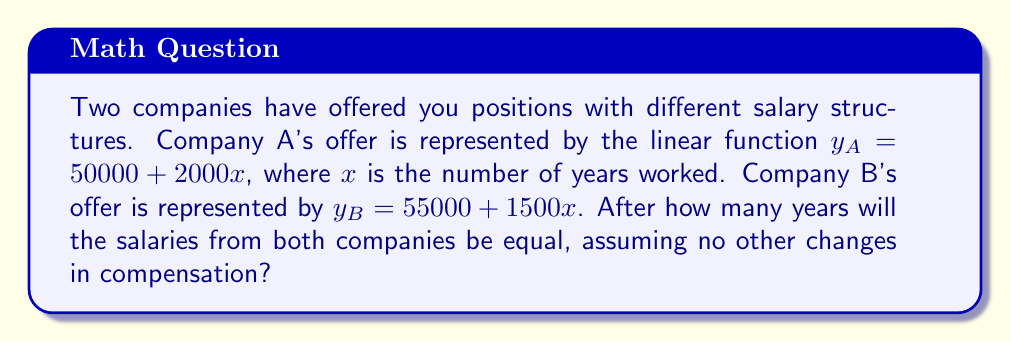Provide a solution to this math problem. To find the point of intersection between these two linear functions, we need to set them equal to each other and solve for $x$:

1) Set the equations equal:
   $y_A = y_B$
   $50000 + 2000x = 55000 + 1500x$

2) Subtract 50000 from both sides:
   $2000x = 5000 + 1500x$

3) Subtract 1500x from both sides:
   $500x = 5000$

4) Divide both sides by 500:
   $x = 10$

5) To verify, we can substitute $x = 10$ into both original equations:
   
   For Company A: $y_A = 50000 + 2000(10) = 70000$
   For Company B: $y_B = 55000 + 1500(10) = 70000$

Therefore, after 10 years, the salaries from both companies will be equal at $70,000.
Answer: 10 years 